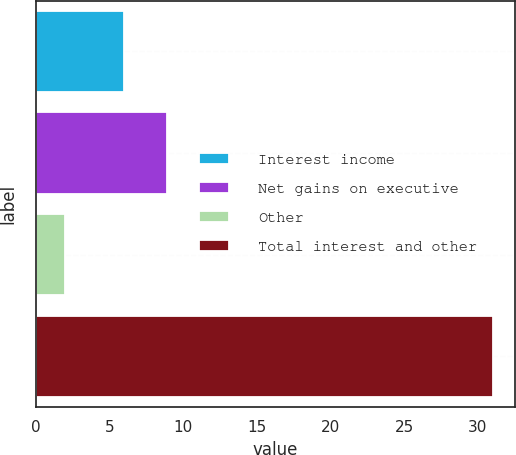<chart> <loc_0><loc_0><loc_500><loc_500><bar_chart><fcel>Interest income<fcel>Net gains on executive<fcel>Other<fcel>Total interest and other<nl><fcel>6<fcel>8.9<fcel>2<fcel>31<nl></chart> 